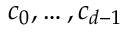<formula> <loc_0><loc_0><loc_500><loc_500>c _ { 0 } , \dots , c _ { d - 1 }</formula> 